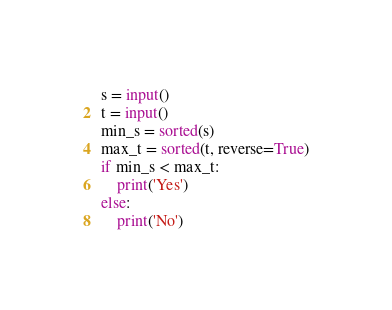Convert code to text. <code><loc_0><loc_0><loc_500><loc_500><_Python_>s = input()
t = input()
min_s = sorted(s)
max_t = sorted(t, reverse=True)
if min_s < max_t:
    print('Yes')
else:
    print('No')</code> 